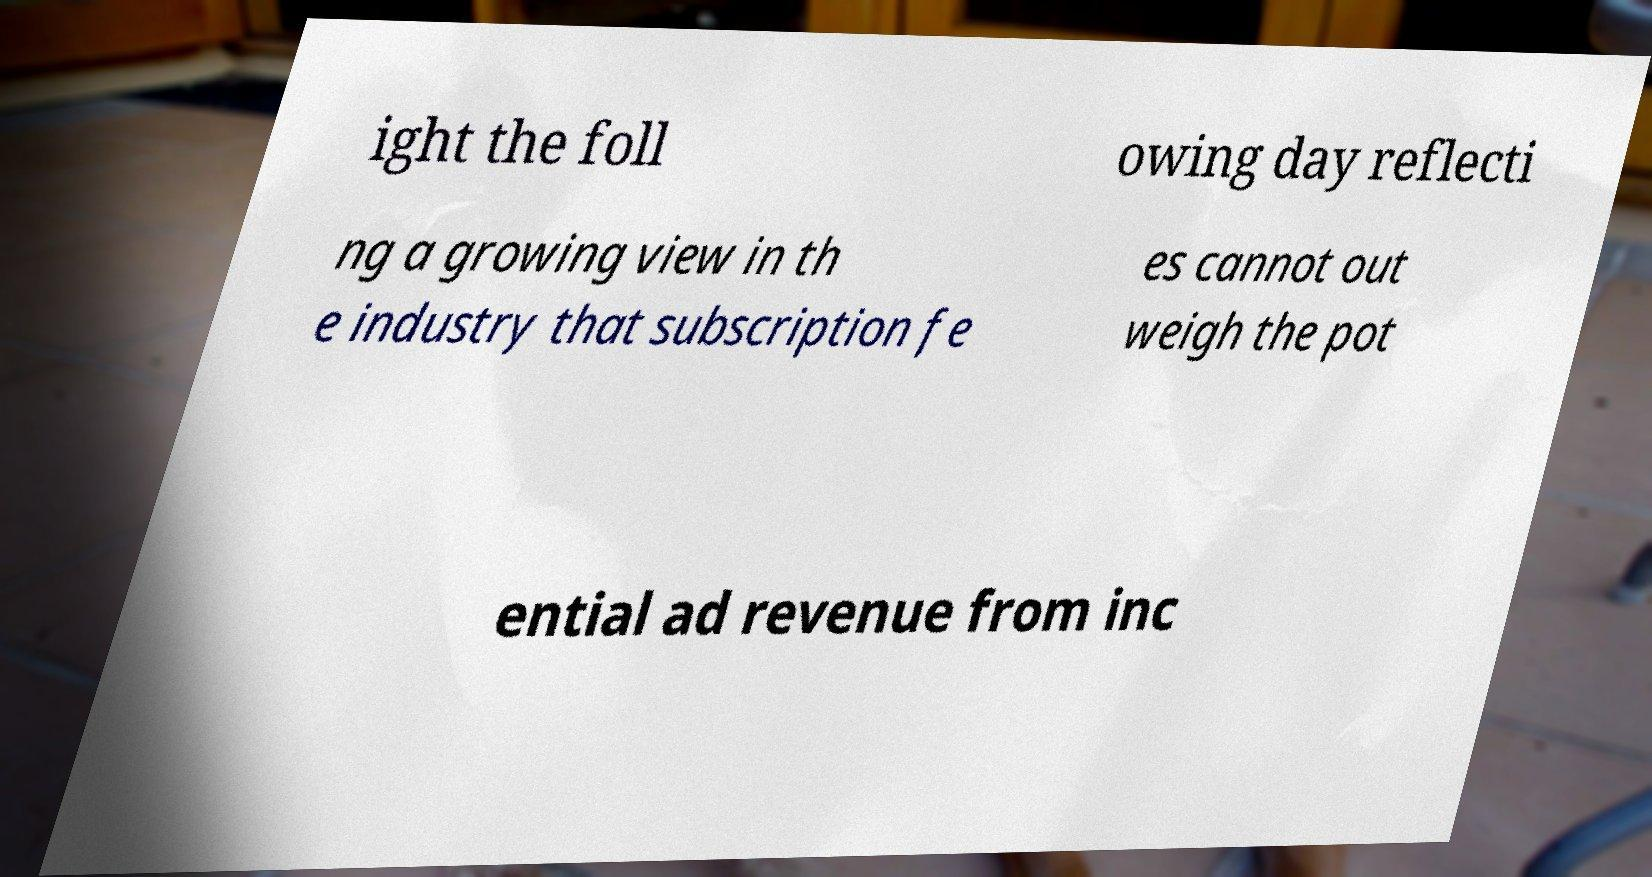There's text embedded in this image that I need extracted. Can you transcribe it verbatim? ight the foll owing day reflecti ng a growing view in th e industry that subscription fe es cannot out weigh the pot ential ad revenue from inc 